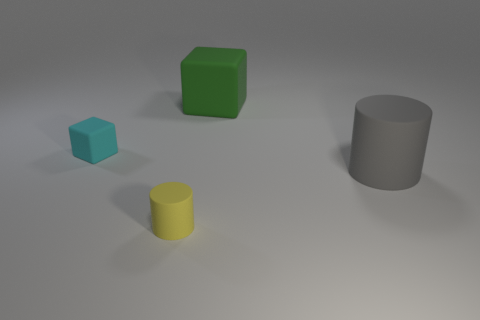The big thing left of the rubber cylinder on the right side of the yellow object is what shape?
Offer a very short reply. Cube. There is a small cylinder; are there any blocks to the right of it?
Provide a succinct answer. Yes. What is the color of the big rubber cube?
Your response must be concise. Green. Are there any green cubes that have the same size as the yellow matte object?
Your answer should be very brief. No. Is the number of large objects that are to the left of the small yellow matte thing the same as the number of large cylinders that are on the right side of the tiny cyan rubber object?
Offer a terse response. No. Do the rubber thing in front of the large gray cylinder and the block to the left of the big green rubber block have the same size?
Make the answer very short. Yes. What number of big matte cubes have the same color as the tiny rubber cylinder?
Offer a terse response. 0. Are there more cylinders behind the yellow rubber thing than cyan matte spheres?
Offer a terse response. Yes. Does the yellow thing have the same shape as the gray matte thing?
Give a very brief answer. Yes. How many large gray cylinders are the same material as the green block?
Offer a very short reply. 1. 